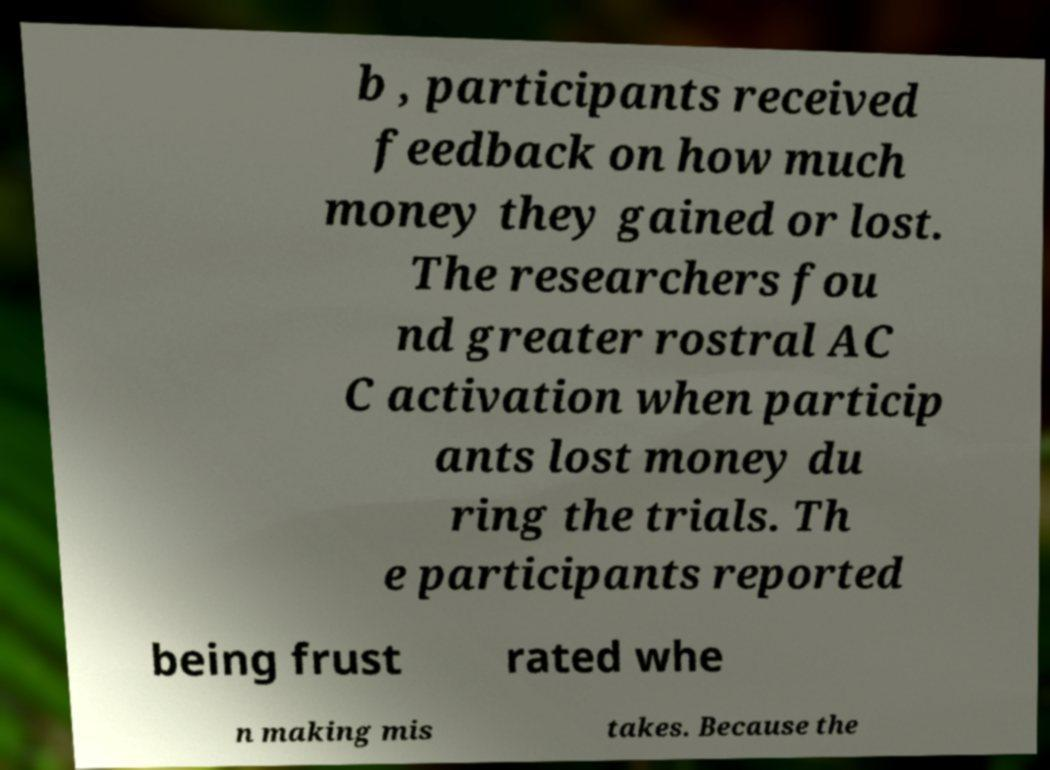Please identify and transcribe the text found in this image. b , participants received feedback on how much money they gained or lost. The researchers fou nd greater rostral AC C activation when particip ants lost money du ring the trials. Th e participants reported being frust rated whe n making mis takes. Because the 